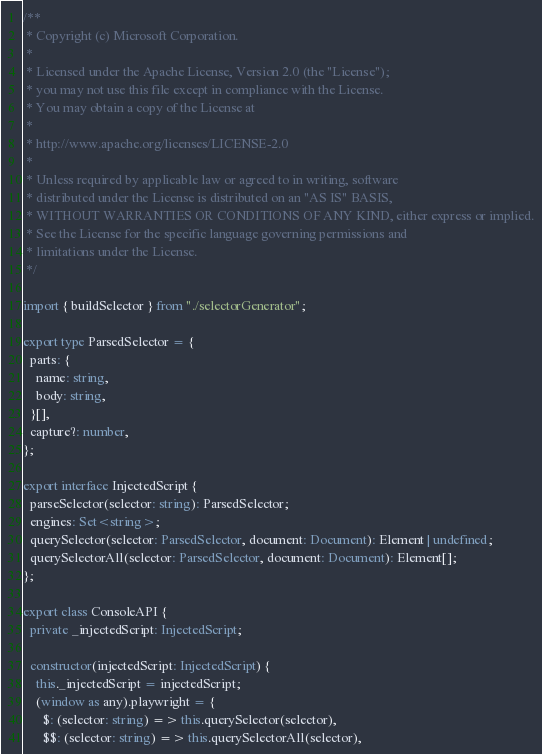<code> <loc_0><loc_0><loc_500><loc_500><_TypeScript_>/**
 * Copyright (c) Microsoft Corporation.
 *
 * Licensed under the Apache License, Version 2.0 (the "License");
 * you may not use this file except in compliance with the License.
 * You may obtain a copy of the License at
 *
 * http://www.apache.org/licenses/LICENSE-2.0
 *
 * Unless required by applicable law or agreed to in writing, software
 * distributed under the License is distributed on an "AS IS" BASIS,
 * WITHOUT WARRANTIES OR CONDITIONS OF ANY KIND, either express or implied.
 * See the License for the specific language governing permissions and
 * limitations under the License.
 */

import { buildSelector } from "./selectorGenerator";

export type ParsedSelector = {
  parts: {
    name: string,
    body: string,
  }[],
  capture?: number,
};

export interface InjectedScript {
  parseSelector(selector: string): ParsedSelector;
  engines: Set<string>;
  querySelector(selector: ParsedSelector, document: Document): Element | undefined;
  querySelectorAll(selector: ParsedSelector, document: Document): Element[];
};

export class ConsoleAPI {
  private _injectedScript: InjectedScript;

  constructor(injectedScript: InjectedScript) {
    this._injectedScript = injectedScript;
    (window as any).playwright = {
      $: (selector: string) => this.querySelector(selector),
      $$: (selector: string) => this.querySelectorAll(selector),</code> 